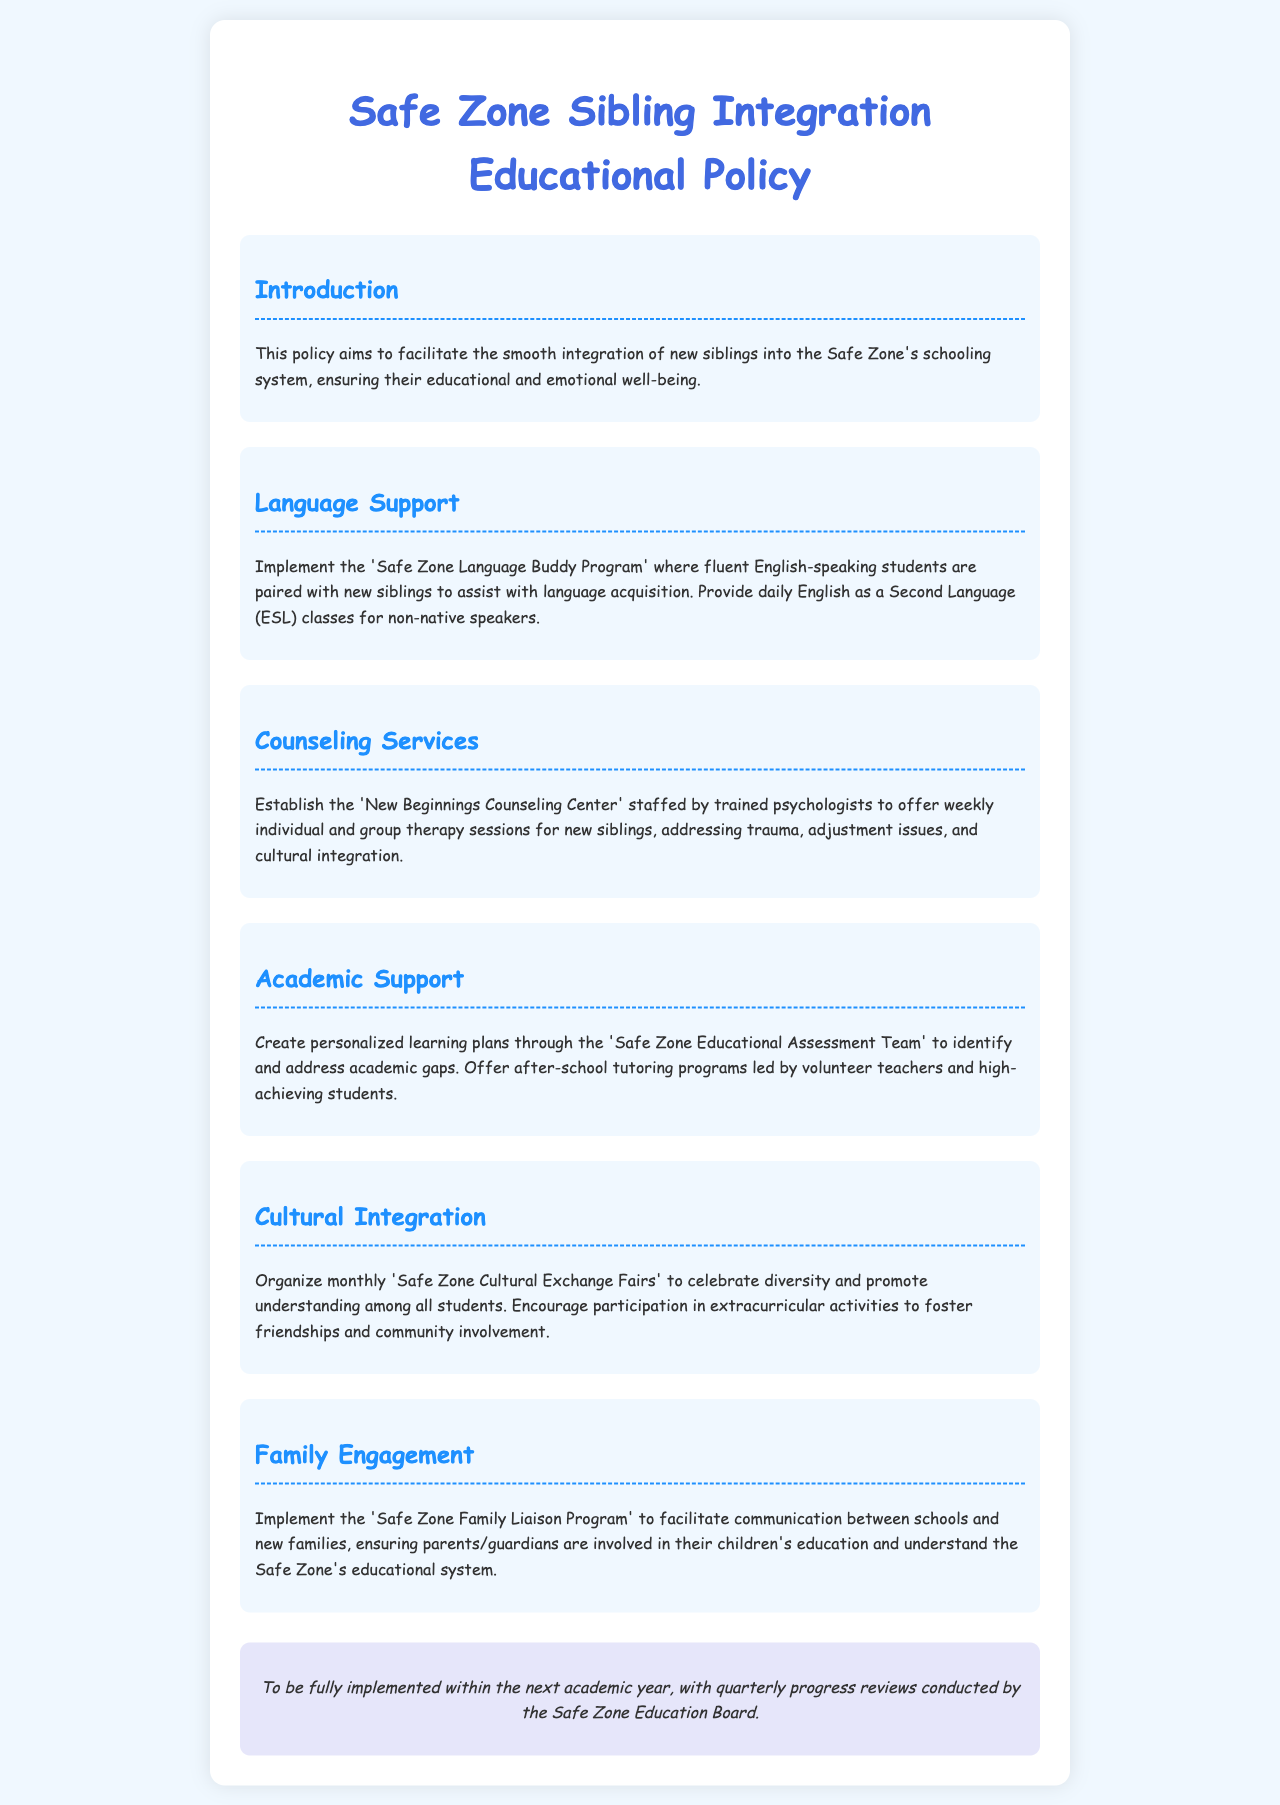What is the objective of the policy? The policy aims to facilitate the smooth integration of new siblings into the Safe Zone's schooling system, ensuring their educational and emotional well-being.
Answer: facilitate smooth integration What program will help with language acquisition? The document mentions the 'Safe Zone Language Buddy Program' for assisting with language acquisition.
Answer: Safe Zone Language Buddy Program What kind of support does the 'New Beginnings Counseling Center' provide? It offers weekly individual and group therapy sessions addressing trauma, adjustment issues, and cultural integration.
Answer: therapy sessions How often are progress reviews conducted? The document states that quarterly progress reviews will be conducted by the Safe Zone Education Board.
Answer: quarterly What is created by the 'Safe Zone Educational Assessment Team'? The team creates personalized learning plans to identify and address academic gaps.
Answer: personalized learning plans What type of events are organized to promote cultural integration? Monthly 'Safe Zone Cultural Exchange Fairs' are organized to celebrate diversity and understanding among students.
Answer: Cultural Exchange Fairs What is the role of the 'Safe Zone Family Liaison Program'? The program facilitates communication between schools and new families, ensuring parental involvement in education.
Answer: facilitate communication How many types of support services are listed in the document? The document outlines four types of support services: language support, counseling, academic support, and cultural integration.
Answer: four What is the intended implementation timeframe for the policy? The policy is to be fully implemented within the next academic year.
Answer: next academic year 